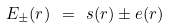<formula> <loc_0><loc_0><loc_500><loc_500>E _ { \pm } ( r ) \ = \ s ( r ) \pm e ( r )</formula> 